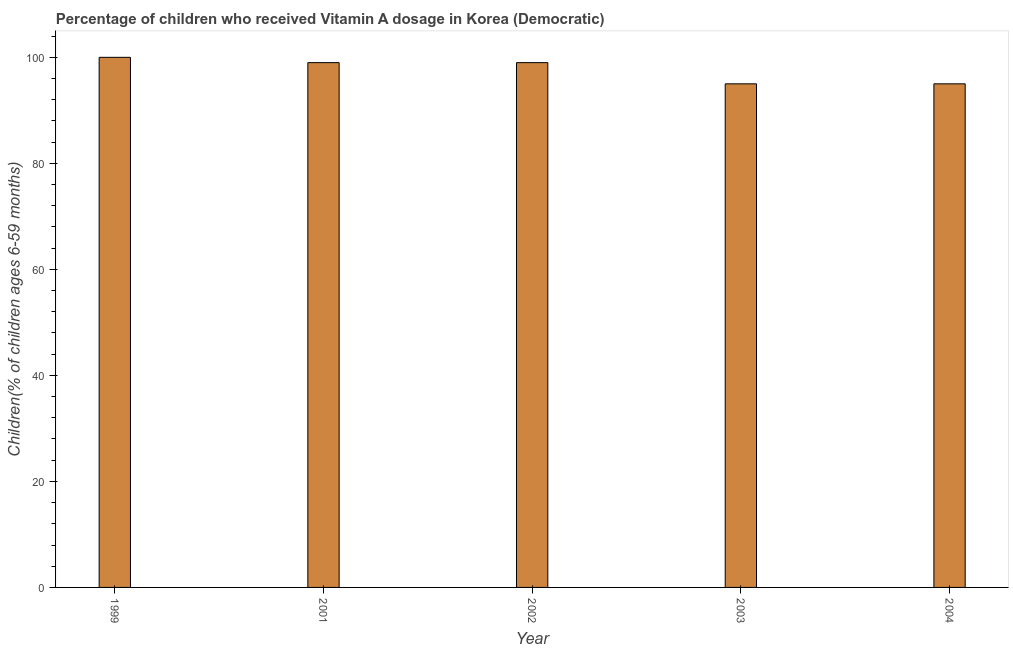Does the graph contain any zero values?
Keep it short and to the point. No. Does the graph contain grids?
Provide a succinct answer. No. What is the title of the graph?
Your response must be concise. Percentage of children who received Vitamin A dosage in Korea (Democratic). What is the label or title of the X-axis?
Your response must be concise. Year. What is the label or title of the Y-axis?
Keep it short and to the point. Children(% of children ages 6-59 months). What is the vitamin a supplementation coverage rate in 2004?
Give a very brief answer. 95. Across all years, what is the maximum vitamin a supplementation coverage rate?
Offer a very short reply. 100. In which year was the vitamin a supplementation coverage rate maximum?
Offer a very short reply. 1999. What is the sum of the vitamin a supplementation coverage rate?
Your answer should be compact. 488. What is the average vitamin a supplementation coverage rate per year?
Offer a terse response. 97.6. Do a majority of the years between 1999 and 2004 (inclusive) have vitamin a supplementation coverage rate greater than 52 %?
Give a very brief answer. Yes. What is the ratio of the vitamin a supplementation coverage rate in 2002 to that in 2004?
Keep it short and to the point. 1.04. What is the difference between the highest and the second highest vitamin a supplementation coverage rate?
Your answer should be compact. 1. In how many years, is the vitamin a supplementation coverage rate greater than the average vitamin a supplementation coverage rate taken over all years?
Make the answer very short. 3. How many bars are there?
Make the answer very short. 5. How many years are there in the graph?
Offer a terse response. 5. What is the Children(% of children ages 6-59 months) of 2003?
Offer a terse response. 95. What is the difference between the Children(% of children ages 6-59 months) in 1999 and 2001?
Make the answer very short. 1. What is the difference between the Children(% of children ages 6-59 months) in 2001 and 2002?
Provide a succinct answer. 0. What is the difference between the Children(% of children ages 6-59 months) in 2001 and 2004?
Make the answer very short. 4. What is the ratio of the Children(% of children ages 6-59 months) in 1999 to that in 2002?
Ensure brevity in your answer.  1.01. What is the ratio of the Children(% of children ages 6-59 months) in 1999 to that in 2003?
Your answer should be compact. 1.05. What is the ratio of the Children(% of children ages 6-59 months) in 1999 to that in 2004?
Your answer should be compact. 1.05. What is the ratio of the Children(% of children ages 6-59 months) in 2001 to that in 2003?
Your answer should be very brief. 1.04. What is the ratio of the Children(% of children ages 6-59 months) in 2001 to that in 2004?
Provide a succinct answer. 1.04. What is the ratio of the Children(% of children ages 6-59 months) in 2002 to that in 2003?
Keep it short and to the point. 1.04. What is the ratio of the Children(% of children ages 6-59 months) in 2002 to that in 2004?
Your answer should be compact. 1.04. What is the ratio of the Children(% of children ages 6-59 months) in 2003 to that in 2004?
Provide a succinct answer. 1. 